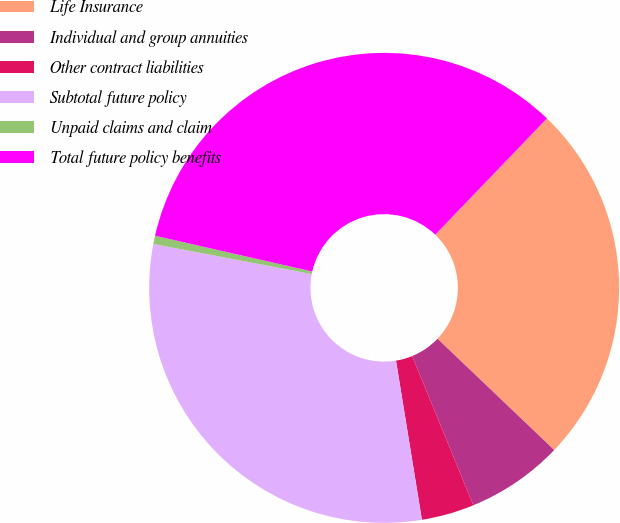Convert chart to OTSL. <chart><loc_0><loc_0><loc_500><loc_500><pie_chart><fcel>Life Insurance<fcel>Individual and group annuities<fcel>Other contract liabilities<fcel>Subtotal future policy<fcel>Unpaid claims and claim<fcel>Total future policy benefits<nl><fcel>24.94%<fcel>6.68%<fcel>3.63%<fcel>30.56%<fcel>0.57%<fcel>33.62%<nl></chart> 